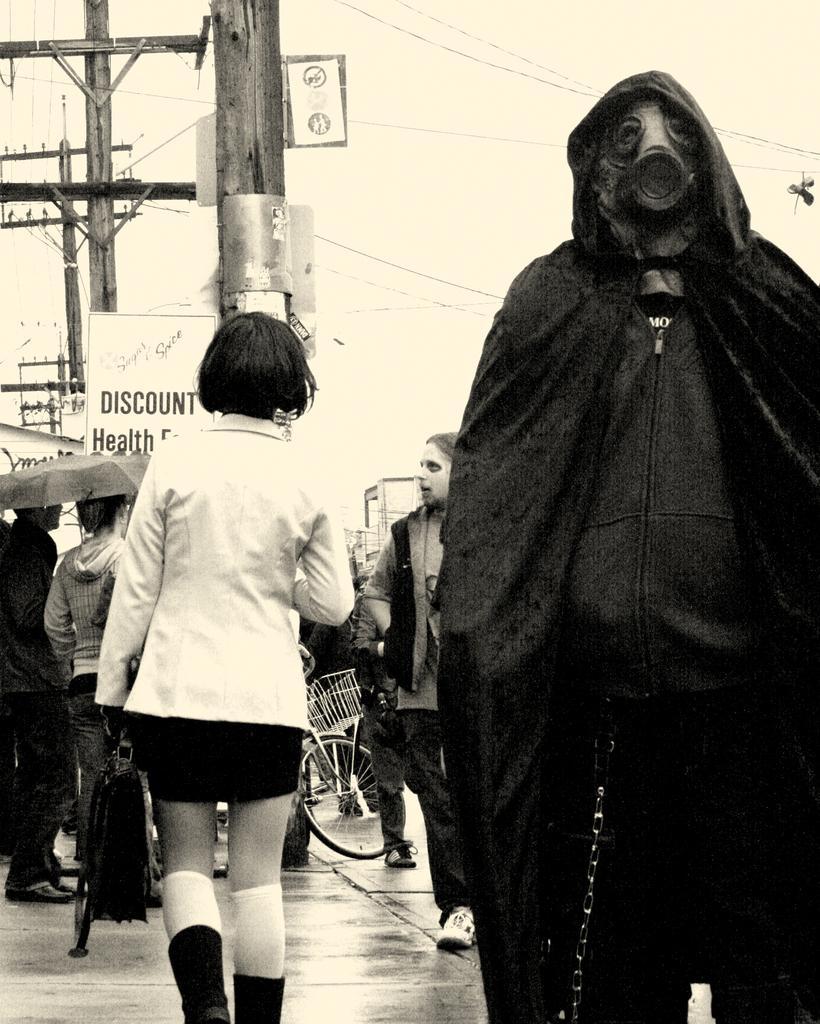Could you give a brief overview of what you see in this image? Black and white picture. Here we can see current pole, boards, wheel and people. This person is holding a bag. This is an umbrella. 